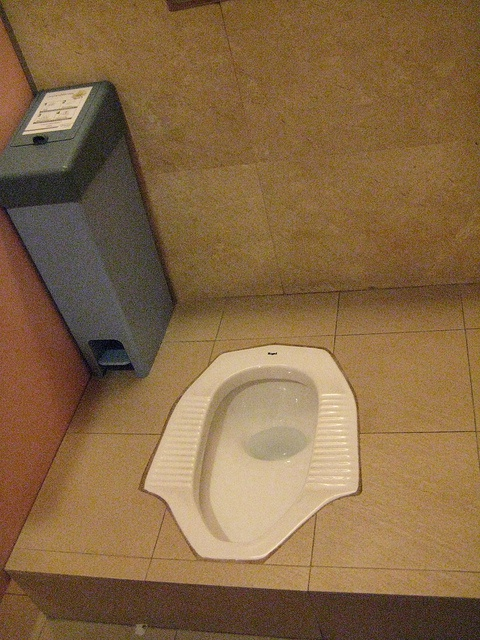Describe the objects in this image and their specific colors. I can see a toilet in maroon and tan tones in this image. 